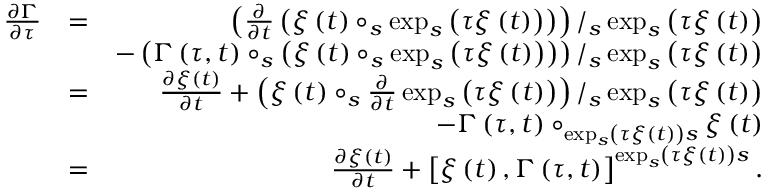Convert formula to latex. <formula><loc_0><loc_0><loc_500><loc_500>\begin{array} { r l r } { \frac { \partial \Gamma } { \partial \tau } } & { = } & { \left ( \frac { \partial } { \partial t } \left ( \xi \left ( t \right ) \circ _ { s } \exp _ { s } \left ( \tau \xi \left ( t \right ) \right ) \right ) \right ) / _ { s } \exp _ { s } \left ( \tau \xi \left ( t \right ) \right ) } \\ & { - \left ( \Gamma \left ( \tau , t \right ) \circ _ { s } \left ( \xi \left ( t \right ) \circ _ { s } \exp _ { s } \left ( \tau \xi \left ( t \right ) \right ) \right ) \right ) / _ { s } \exp _ { s } \left ( \tau \xi \left ( t \right ) \right ) } \\ & { = } & { \frac { \partial \xi \left ( t \right ) } { \partial t } + \left ( \xi \left ( t \right ) \circ _ { s } \frac { \partial } { \partial t } \exp _ { s } \left ( \tau \xi \left ( t \right ) \right ) \right ) / _ { s } \exp _ { s } \left ( \tau \xi \left ( t \right ) \right ) } \\ & { - \Gamma \left ( \tau , t \right ) \circ _ { \exp _ { s } \left ( \tau \xi \left ( t \right ) \right ) s } \xi \left ( t \right ) } \\ & { = } & { \frac { \partial \xi \left ( t \right ) } { \partial t } + \left [ \xi \left ( t \right ) , \Gamma \left ( \tau , t \right ) \right ] ^ { \exp _ { s } \left ( \tau \xi \left ( t \right ) \right ) s } . } \end{array}</formula> 